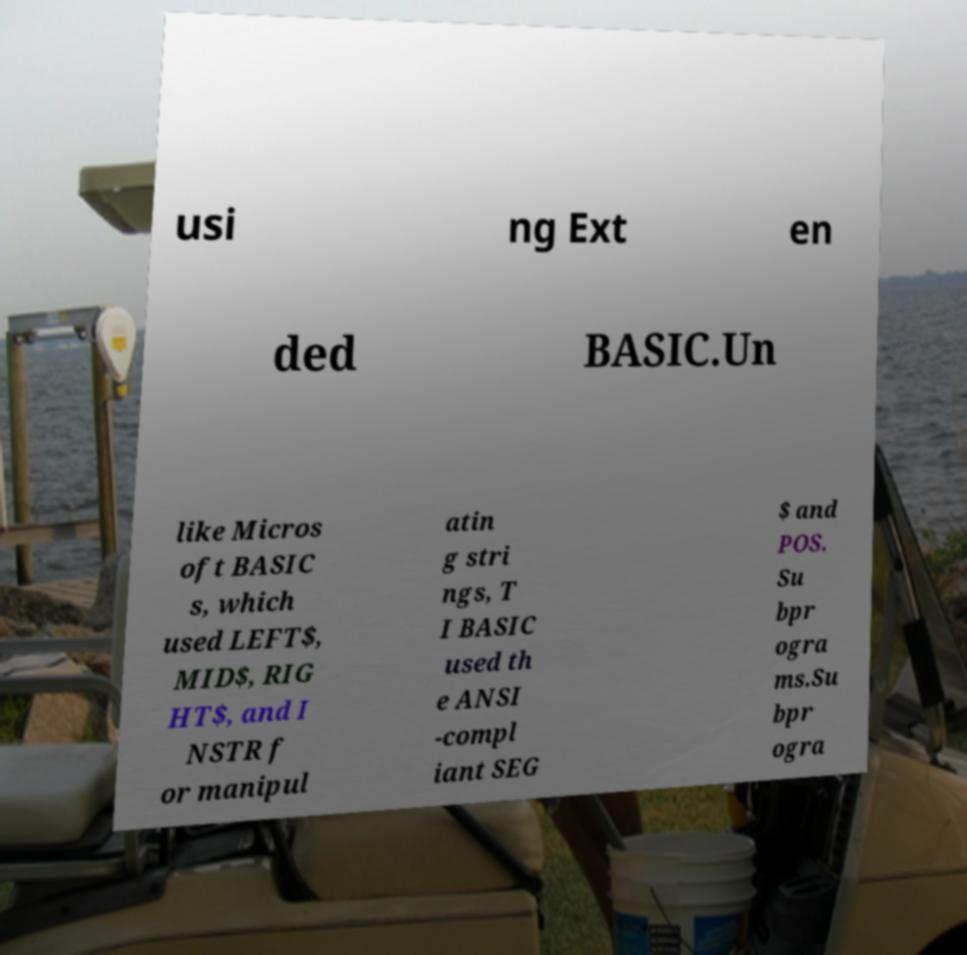What messages or text are displayed in this image? I need them in a readable, typed format. usi ng Ext en ded BASIC.Un like Micros oft BASIC s, which used LEFT$, MID$, RIG HT$, and I NSTR f or manipul atin g stri ngs, T I BASIC used th e ANSI -compl iant SEG $ and POS. Su bpr ogra ms.Su bpr ogra 